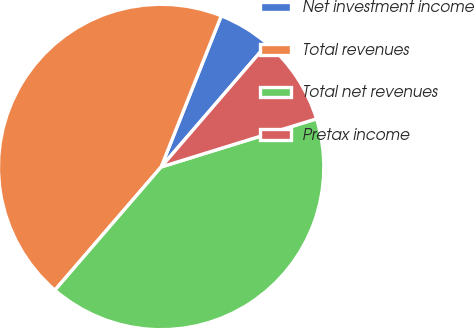<chart> <loc_0><loc_0><loc_500><loc_500><pie_chart><fcel>Net investment income<fcel>Total revenues<fcel>Total net revenues<fcel>Pretax income<nl><fcel>5.3%<fcel>44.7%<fcel>41.11%<fcel>8.89%<nl></chart> 